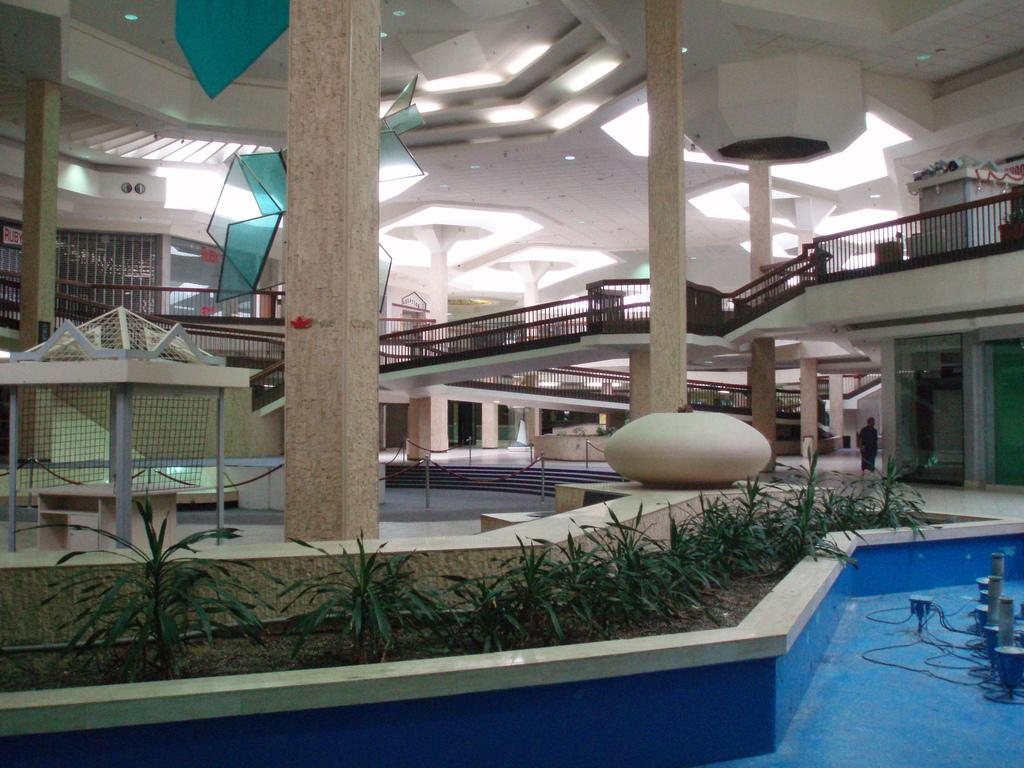What type of structure is present in the image? There is a house in the image. What can be seen growing or decorating the house? There are plants in the image. What architectural features are present in the house? There are pillars, walls, and a roof visible in the image. Are there any additional elements that provide support or decoration? Yes, there are railings in the image. Can you describe any specific details about the house? There is a stone on a wall in the image. What can be seen illuminating the house or its surroundings? There are lights in the image. Where is the swing located in the image? There is no swing present in the image. What invention is being showcased in the image? There is no specific invention being showcased in the image; it primarily features a house with various elements. Can you describe any cobwebs present in the image? There is no mention of cobwebs in the provided facts, and therefore, we cannot determine if any are present in the image. 